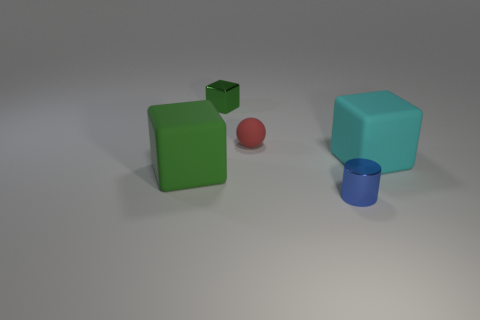Add 3 green metal cubes. How many objects exist? 8 Subtract all cylinders. How many objects are left? 4 Add 3 large cyan matte things. How many large cyan matte things are left? 4 Add 1 tiny cylinders. How many tiny cylinders exist? 2 Subtract 0 yellow cylinders. How many objects are left? 5 Subtract all green shiny balls. Subtract all red rubber spheres. How many objects are left? 4 